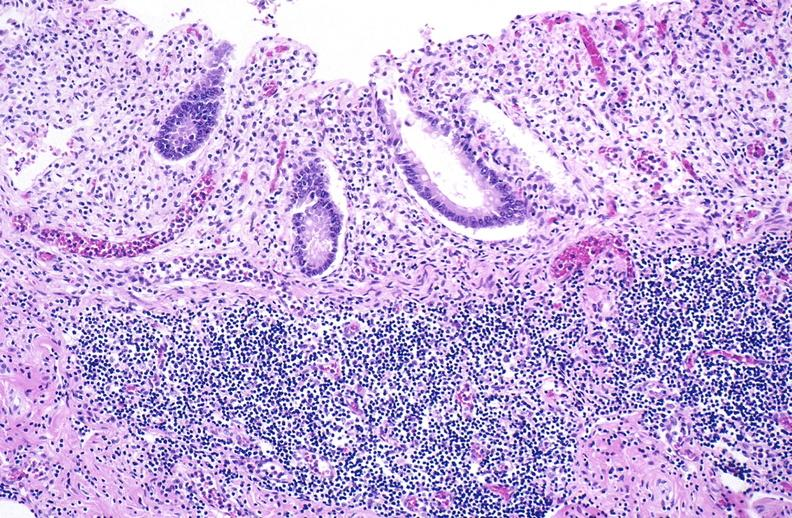where is this from?
Answer the question using a single word or phrase. Gastrointestinal system 